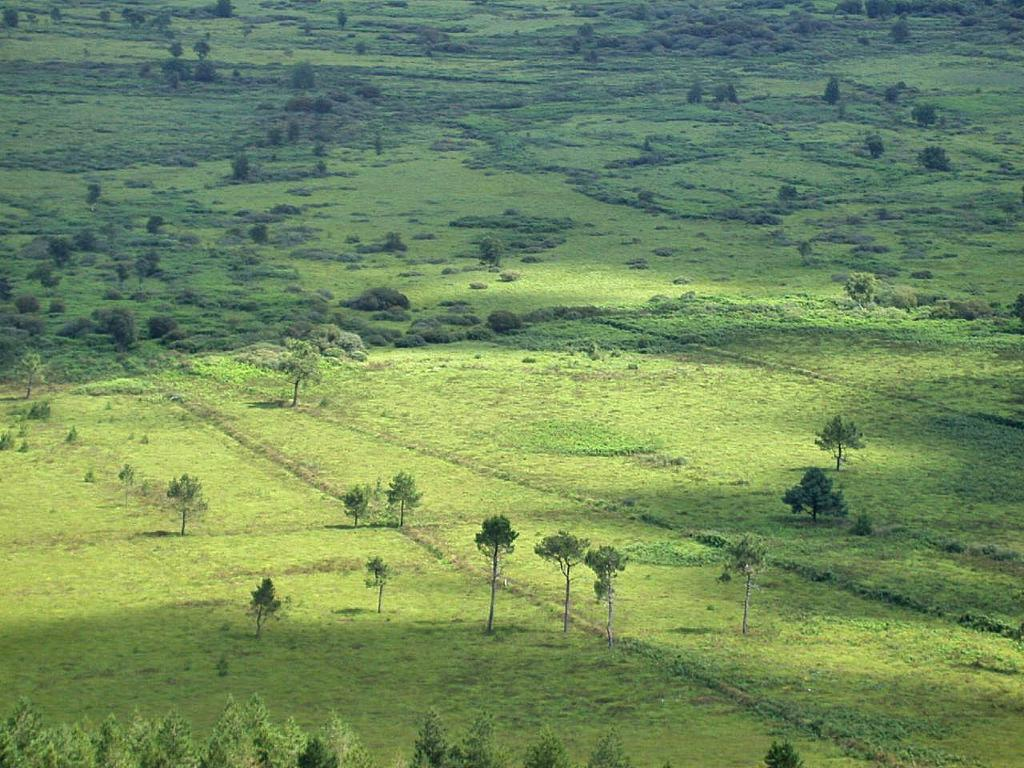Where was the picture taken? The picture was clicked outside. What type of vegetation can be seen in the image? There is green grass, plants, and trees in the image. How far away is the achiever from the camera in the image? There is no achiever present in the image; it features green grass, plants, and trees. 